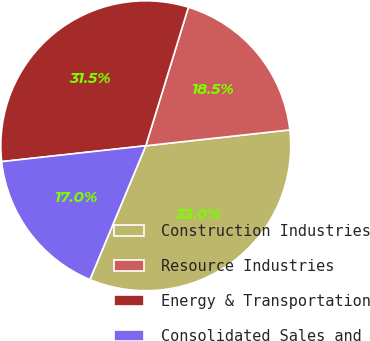<chart> <loc_0><loc_0><loc_500><loc_500><pie_chart><fcel>Construction Industries<fcel>Resource Industries<fcel>Energy & Transportation<fcel>Consolidated Sales and<nl><fcel>33.04%<fcel>18.5%<fcel>31.5%<fcel>16.96%<nl></chart> 